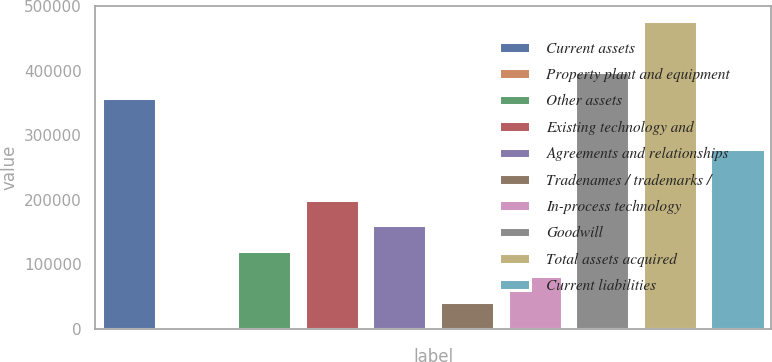Convert chart to OTSL. <chart><loc_0><loc_0><loc_500><loc_500><bar_chart><fcel>Current assets<fcel>Property plant and equipment<fcel>Other assets<fcel>Existing technology and<fcel>Agreements and relationships<fcel>Tradenames / trademarks /<fcel>In-process technology<fcel>Goodwill<fcel>Total assets acquired<fcel>Current liabilities<nl><fcel>358029<fcel>2509<fcel>121016<fcel>200020<fcel>160518<fcel>42011.2<fcel>81513.4<fcel>397531<fcel>476535<fcel>279024<nl></chart> 